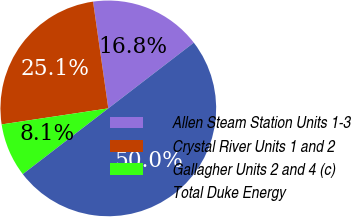<chart> <loc_0><loc_0><loc_500><loc_500><pie_chart><fcel>Allen Steam Station Units 1-3<fcel>Crystal River Units 1 and 2<fcel>Gallagher Units 2 and 4 (c)<fcel>Total Duke Energy<nl><fcel>16.83%<fcel>25.12%<fcel>8.06%<fcel>50.0%<nl></chart> 